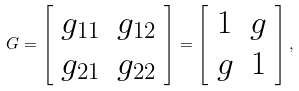Convert formula to latex. <formula><loc_0><loc_0><loc_500><loc_500>G = \left [ \begin{array} { c c } g _ { 1 1 } & g _ { 1 2 } \\ g _ { 2 1 } & g _ { 2 2 } \end{array} \right ] = \left [ \begin{array} { c c } 1 & g \\ g & 1 \end{array} \right ] ,</formula> 